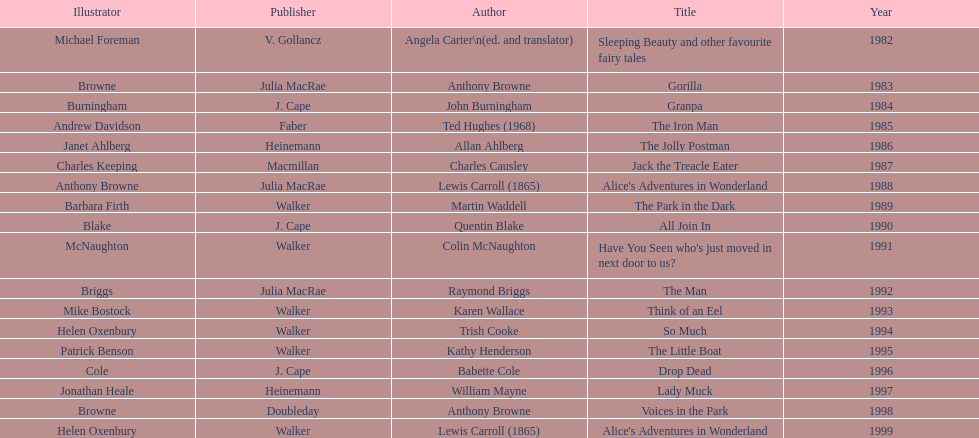Which book won the award a total of 2 times? Alice's Adventures in Wonderland. 